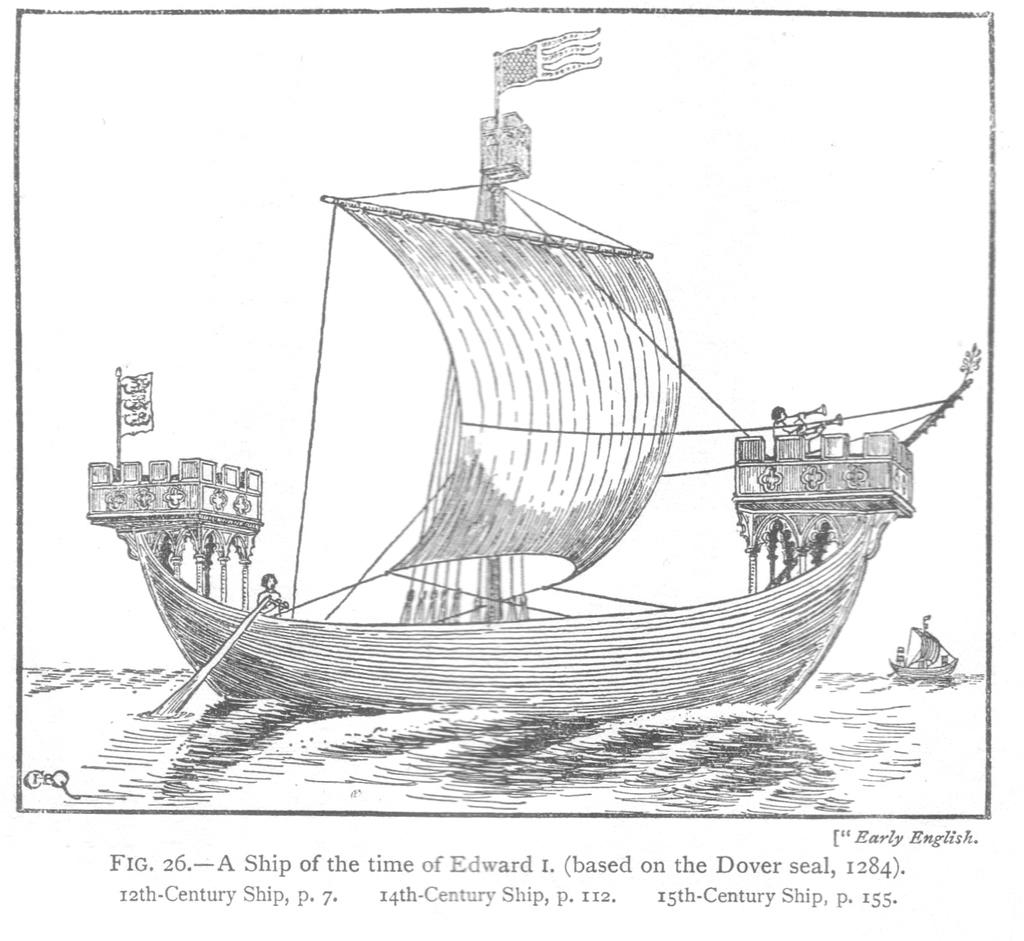What is depicted in the drawing above the water in the image? There is a drawing of boats above the water in the image. Can you describe the scene involving the boats? There are people in a boat in the scene. What is written or displayed at the bottom of the image? There is text at the bottom of the image. How many matches are being played by the women in the image? There are no women or matches present in the image; it features a drawing of boats with people in them and text at the bottom. 